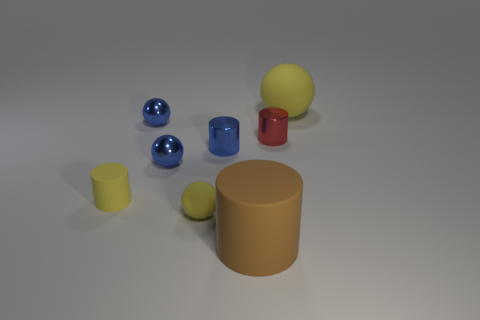How many objects are small red objects or tiny red metal cylinders that are behind the blue metallic cylinder?
Offer a very short reply. 1. There is a brown cylinder; is its size the same as the yellow sphere that is in front of the large rubber sphere?
Ensure brevity in your answer.  No. How many cylinders are blue objects or small green shiny things?
Provide a short and direct response. 1. What number of spheres are on the left side of the tiny red metal thing and behind the red shiny object?
Provide a short and direct response. 1. How many other things are the same color as the small matte sphere?
Provide a succinct answer. 2. The big matte object in front of the large ball has what shape?
Offer a very short reply. Cylinder. Do the small yellow ball and the large cylinder have the same material?
Give a very brief answer. Yes. There is a red cylinder; what number of small red shiny objects are behind it?
Give a very brief answer. 0. What shape is the tiny blue thing behind the shiny cylinder that is left of the brown object?
Offer a very short reply. Sphere. Are there more small blue cylinders that are behind the brown thing than large matte cylinders?
Keep it short and to the point. No. 